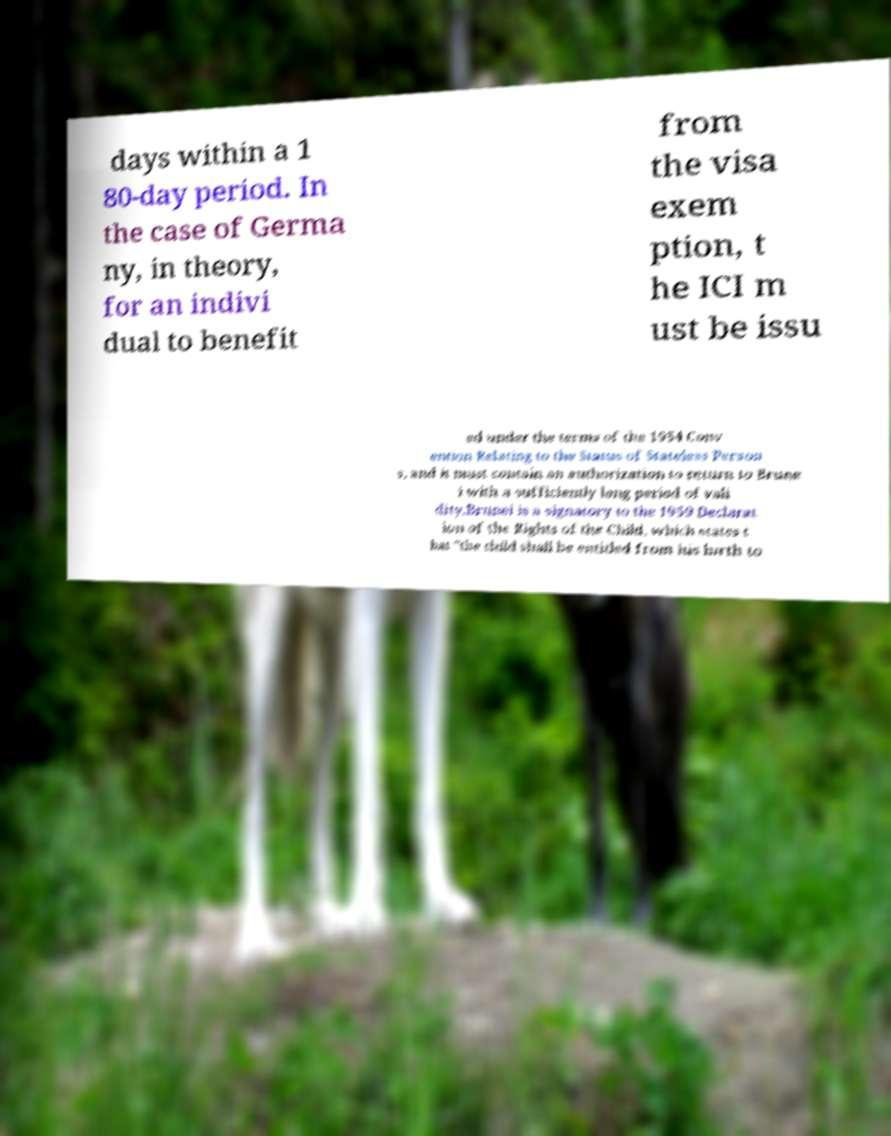Can you read and provide the text displayed in the image?This photo seems to have some interesting text. Can you extract and type it out for me? days within a 1 80-day period. In the case of Germa ny, in theory, for an indivi dual to benefit from the visa exem ption, t he ICI m ust be issu ed under the terms of the 1954 Conv ention Relating to the Status of Stateless Person s, and it must contain an authorization to return to Brune i with a sufficiently long period of vali dity.Brunei is a signatory to the 1959 Declarat ion of the Rights of the Child, which states t hat "the child shall be entitled from his birth to 